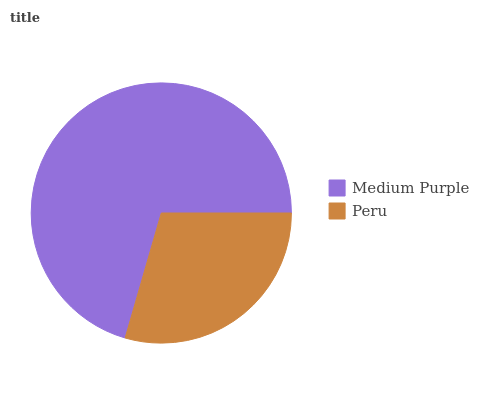Is Peru the minimum?
Answer yes or no. Yes. Is Medium Purple the maximum?
Answer yes or no. Yes. Is Peru the maximum?
Answer yes or no. No. Is Medium Purple greater than Peru?
Answer yes or no. Yes. Is Peru less than Medium Purple?
Answer yes or no. Yes. Is Peru greater than Medium Purple?
Answer yes or no. No. Is Medium Purple less than Peru?
Answer yes or no. No. Is Medium Purple the high median?
Answer yes or no. Yes. Is Peru the low median?
Answer yes or no. Yes. Is Peru the high median?
Answer yes or no. No. Is Medium Purple the low median?
Answer yes or no. No. 